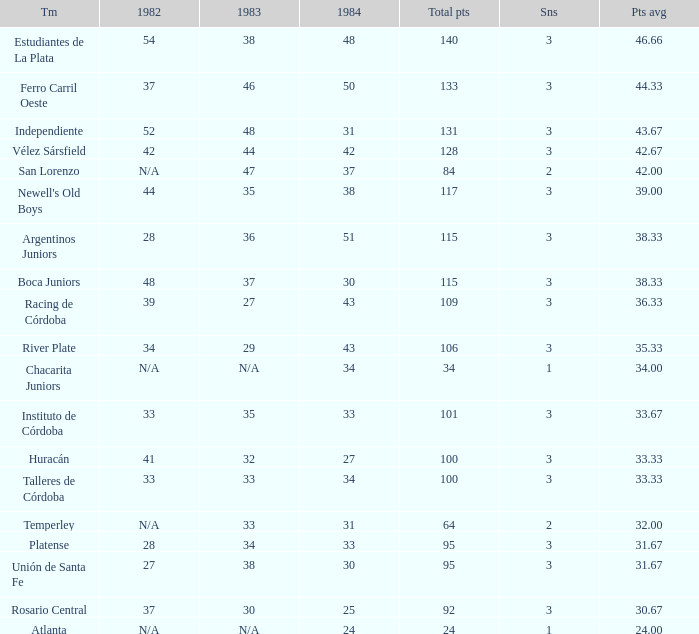What is the total for 1984 for the team with 100 points total and more than 3 seasons? None. 